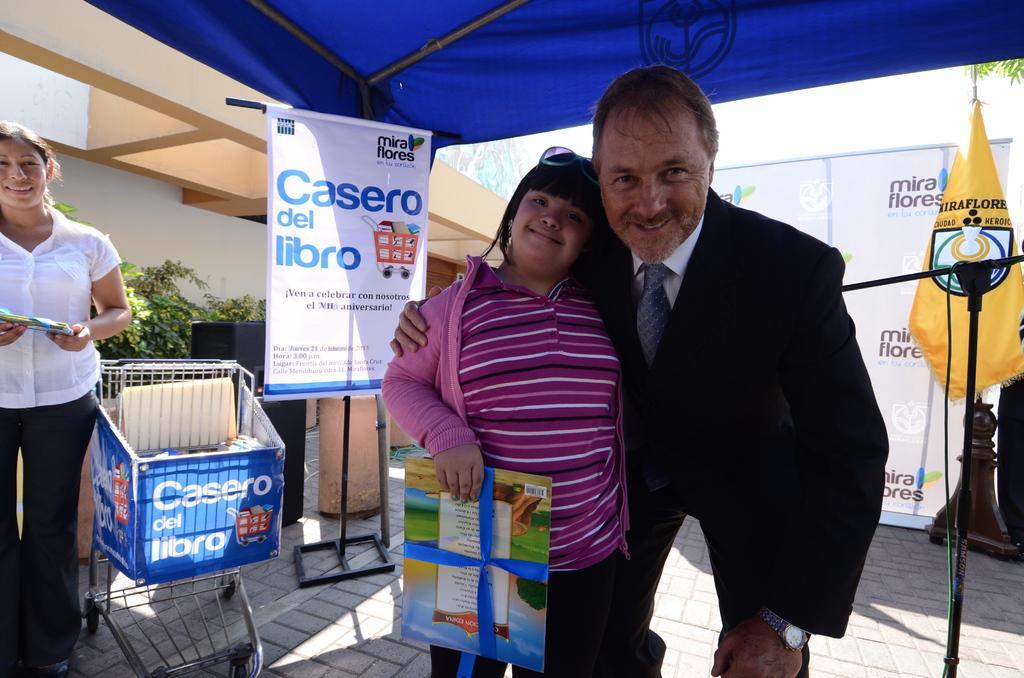Can you describe this image briefly? In the center of the image we can see a girl is standing and holding an object and a man is standing. At the top of the image tent is there. In the background of the image we can see boards, rods are there. On the left side of the image a lady is standing and holding an object and trolley, speaker, plant, wall are there. At the bottom of the image ground is there. 